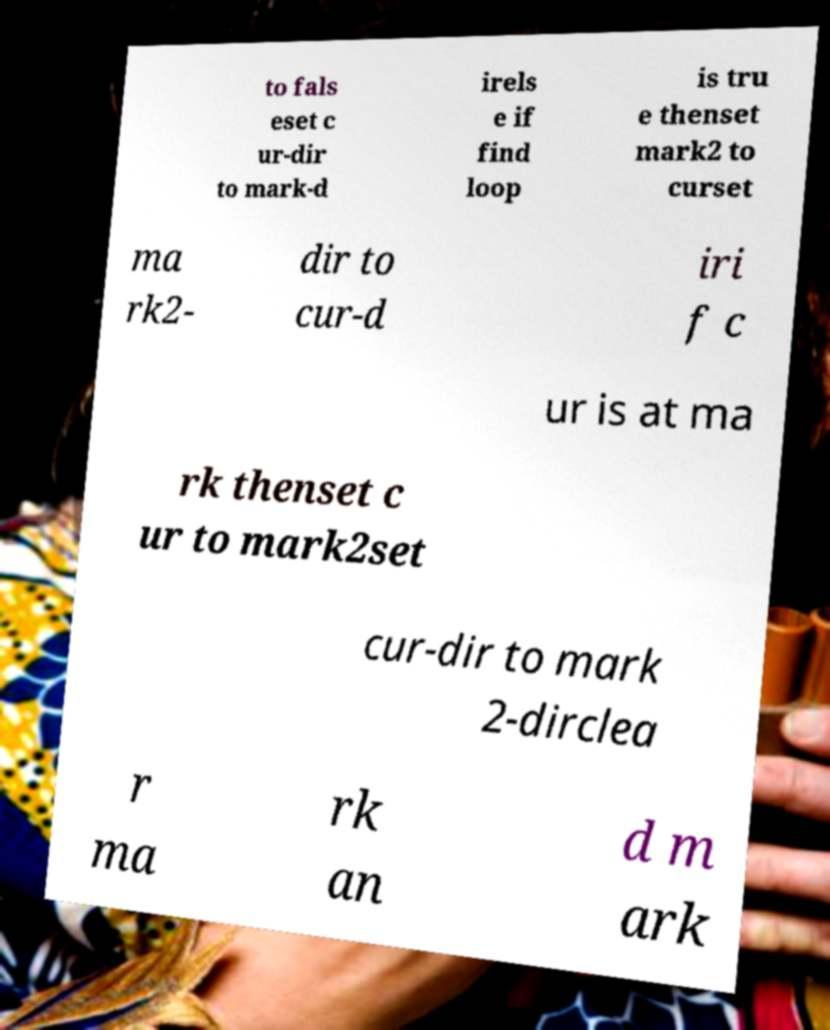Can you accurately transcribe the text from the provided image for me? to fals eset c ur-dir to mark-d irels e if find loop is tru e thenset mark2 to curset ma rk2- dir to cur-d iri f c ur is at ma rk thenset c ur to mark2set cur-dir to mark 2-dirclea r ma rk an d m ark 